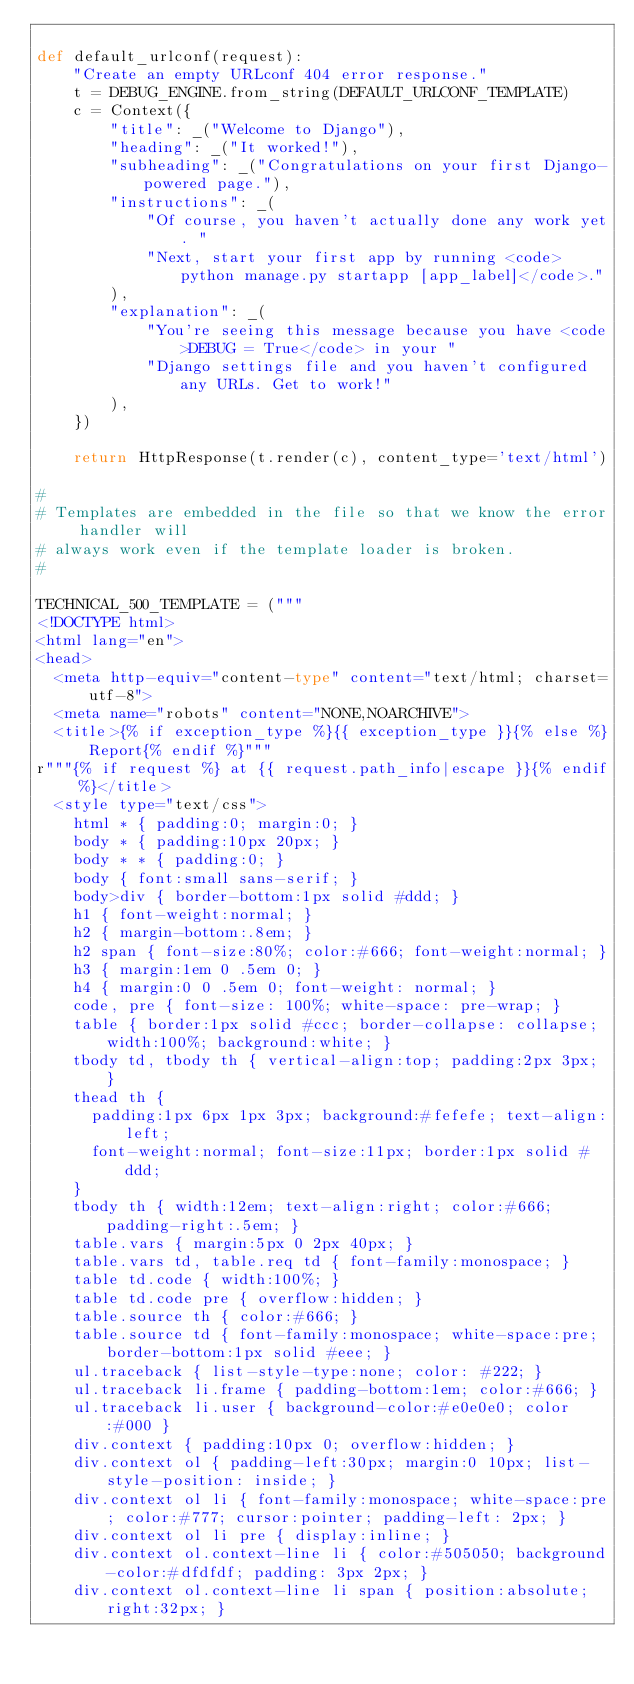<code> <loc_0><loc_0><loc_500><loc_500><_Python_>
def default_urlconf(request):
    "Create an empty URLconf 404 error response."
    t = DEBUG_ENGINE.from_string(DEFAULT_URLCONF_TEMPLATE)
    c = Context({
        "title": _("Welcome to Django"),
        "heading": _("It worked!"),
        "subheading": _("Congratulations on your first Django-powered page."),
        "instructions": _(
            "Of course, you haven't actually done any work yet. "
            "Next, start your first app by running <code>python manage.py startapp [app_label]</code>."
        ),
        "explanation": _(
            "You're seeing this message because you have <code>DEBUG = True</code> in your "
            "Django settings file and you haven't configured any URLs. Get to work!"
        ),
    })

    return HttpResponse(t.render(c), content_type='text/html')

#
# Templates are embedded in the file so that we know the error handler will
# always work even if the template loader is broken.
#

TECHNICAL_500_TEMPLATE = ("""
<!DOCTYPE html>
<html lang="en">
<head>
  <meta http-equiv="content-type" content="text/html; charset=utf-8">
  <meta name="robots" content="NONE,NOARCHIVE">
  <title>{% if exception_type %}{{ exception_type }}{% else %}Report{% endif %}"""
r"""{% if request %} at {{ request.path_info|escape }}{% endif %}</title>
  <style type="text/css">
    html * { padding:0; margin:0; }
    body * { padding:10px 20px; }
    body * * { padding:0; }
    body { font:small sans-serif; }
    body>div { border-bottom:1px solid #ddd; }
    h1 { font-weight:normal; }
    h2 { margin-bottom:.8em; }
    h2 span { font-size:80%; color:#666; font-weight:normal; }
    h3 { margin:1em 0 .5em 0; }
    h4 { margin:0 0 .5em 0; font-weight: normal; }
    code, pre { font-size: 100%; white-space: pre-wrap; }
    table { border:1px solid #ccc; border-collapse: collapse; width:100%; background:white; }
    tbody td, tbody th { vertical-align:top; padding:2px 3px; }
    thead th {
      padding:1px 6px 1px 3px; background:#fefefe; text-align:left;
      font-weight:normal; font-size:11px; border:1px solid #ddd;
    }
    tbody th { width:12em; text-align:right; color:#666; padding-right:.5em; }
    table.vars { margin:5px 0 2px 40px; }
    table.vars td, table.req td { font-family:monospace; }
    table td.code { width:100%; }
    table td.code pre { overflow:hidden; }
    table.source th { color:#666; }
    table.source td { font-family:monospace; white-space:pre; border-bottom:1px solid #eee; }
    ul.traceback { list-style-type:none; color: #222; }
    ul.traceback li.frame { padding-bottom:1em; color:#666; }
    ul.traceback li.user { background-color:#e0e0e0; color:#000 }
    div.context { padding:10px 0; overflow:hidden; }
    div.context ol { padding-left:30px; margin:0 10px; list-style-position: inside; }
    div.context ol li { font-family:monospace; white-space:pre; color:#777; cursor:pointer; padding-left: 2px; }
    div.context ol li pre { display:inline; }
    div.context ol.context-line li { color:#505050; background-color:#dfdfdf; padding: 3px 2px; }
    div.context ol.context-line li span { position:absolute; right:32px; }</code> 